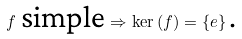<formula> <loc_0><loc_0><loc_500><loc_500>\text { } f \text { simple} \Rightarrow \ker \left ( f \right ) = \left \{ e \right \} \text {.}</formula> 